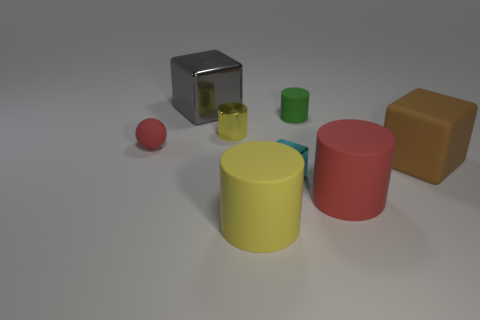Add 1 metal cubes. How many objects exist? 9 Add 8 yellow shiny objects. How many yellow shiny objects exist? 9 Subtract all cyan blocks. How many blocks are left? 2 Subtract all tiny yellow shiny cylinders. How many cylinders are left? 3 Subtract 0 yellow balls. How many objects are left? 8 Subtract all balls. How many objects are left? 7 Subtract 3 cubes. How many cubes are left? 0 Subtract all red cylinders. Subtract all green spheres. How many cylinders are left? 3 Subtract all green cylinders. How many gray blocks are left? 1 Subtract all small red things. Subtract all brown matte things. How many objects are left? 6 